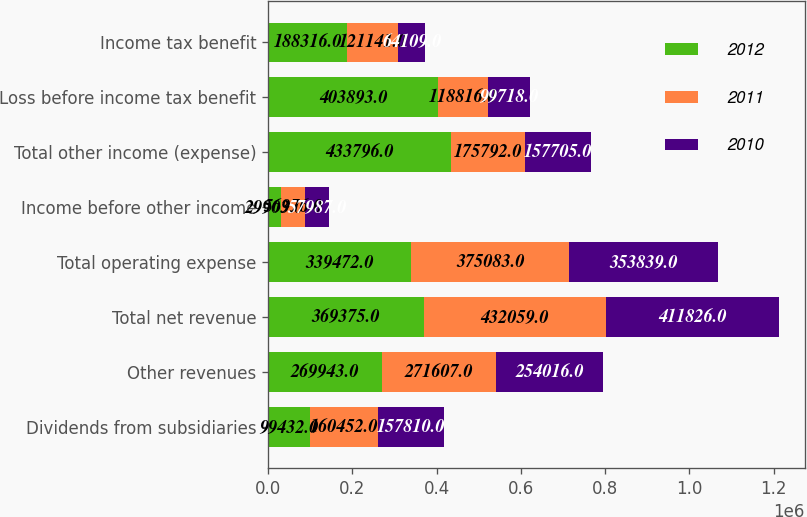<chart> <loc_0><loc_0><loc_500><loc_500><stacked_bar_chart><ecel><fcel>Dividends from subsidiaries<fcel>Other revenues<fcel>Total net revenue<fcel>Total operating expense<fcel>Income before other income<fcel>Total other income (expense)<fcel>Loss before income tax benefit<fcel>Income tax benefit<nl><fcel>2012<fcel>99432<fcel>269943<fcel>369375<fcel>339472<fcel>29903<fcel>433796<fcel>403893<fcel>188316<nl><fcel>2011<fcel>160452<fcel>271607<fcel>432059<fcel>375083<fcel>56976<fcel>175792<fcel>118816<fcel>121141<nl><fcel>2010<fcel>157810<fcel>254016<fcel>411826<fcel>353839<fcel>57987<fcel>157705<fcel>99718<fcel>64109<nl></chart> 